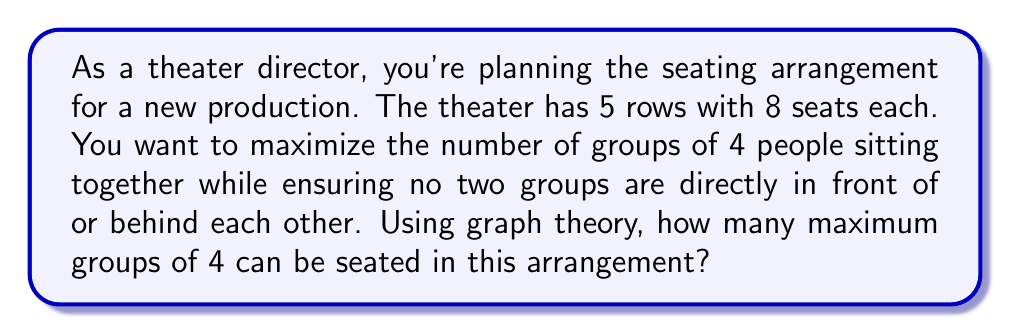Can you answer this question? To solve this problem, we can use graph theory and optimization techniques. Let's approach this step-by-step:

1) First, we need to model the theater as a graph. Each potential group of 4 seats becomes a vertex in our graph.

2) In each row, there are 5 possible groups of 4 consecutive seats (seats 1-4, 2-5, 3-6, 4-7, and 5-8). With 5 rows, we have 25 vertices in total.

3) We create edges between vertices that represent conflicting seating arrangements. Two groups conflict if they are in adjacent rows and overlap.

4) The problem now becomes finding the maximum independent set in this graph. An independent set is a set of vertices where no two vertices are connected by an edge.

5) To visualize this, we can create an adjacency matrix $A$ where:

   $A_{ij} = \begin{cases} 
   1 & \text{if groups i and j conflict} \\
   0 & \text{otherwise}
   \end{cases}$

6) The maximum independent set problem is NP-hard, but for a small graph like this, we can solve it using a simple algorithm:

   - Start with an empty set S
   - While there are unmarked vertices:
     - Choose an unmarked vertex v
     - Add v to S
     - Mark v and all its neighbors

7) Applying this algorithm, we find that the maximum independent set contains 10 vertices.

8) These 10 vertices represent the maximum number of non-conflicting groups of 4 that can be seated.
Answer: The maximum number of groups of 4 that can be seated under these conditions is 10. 